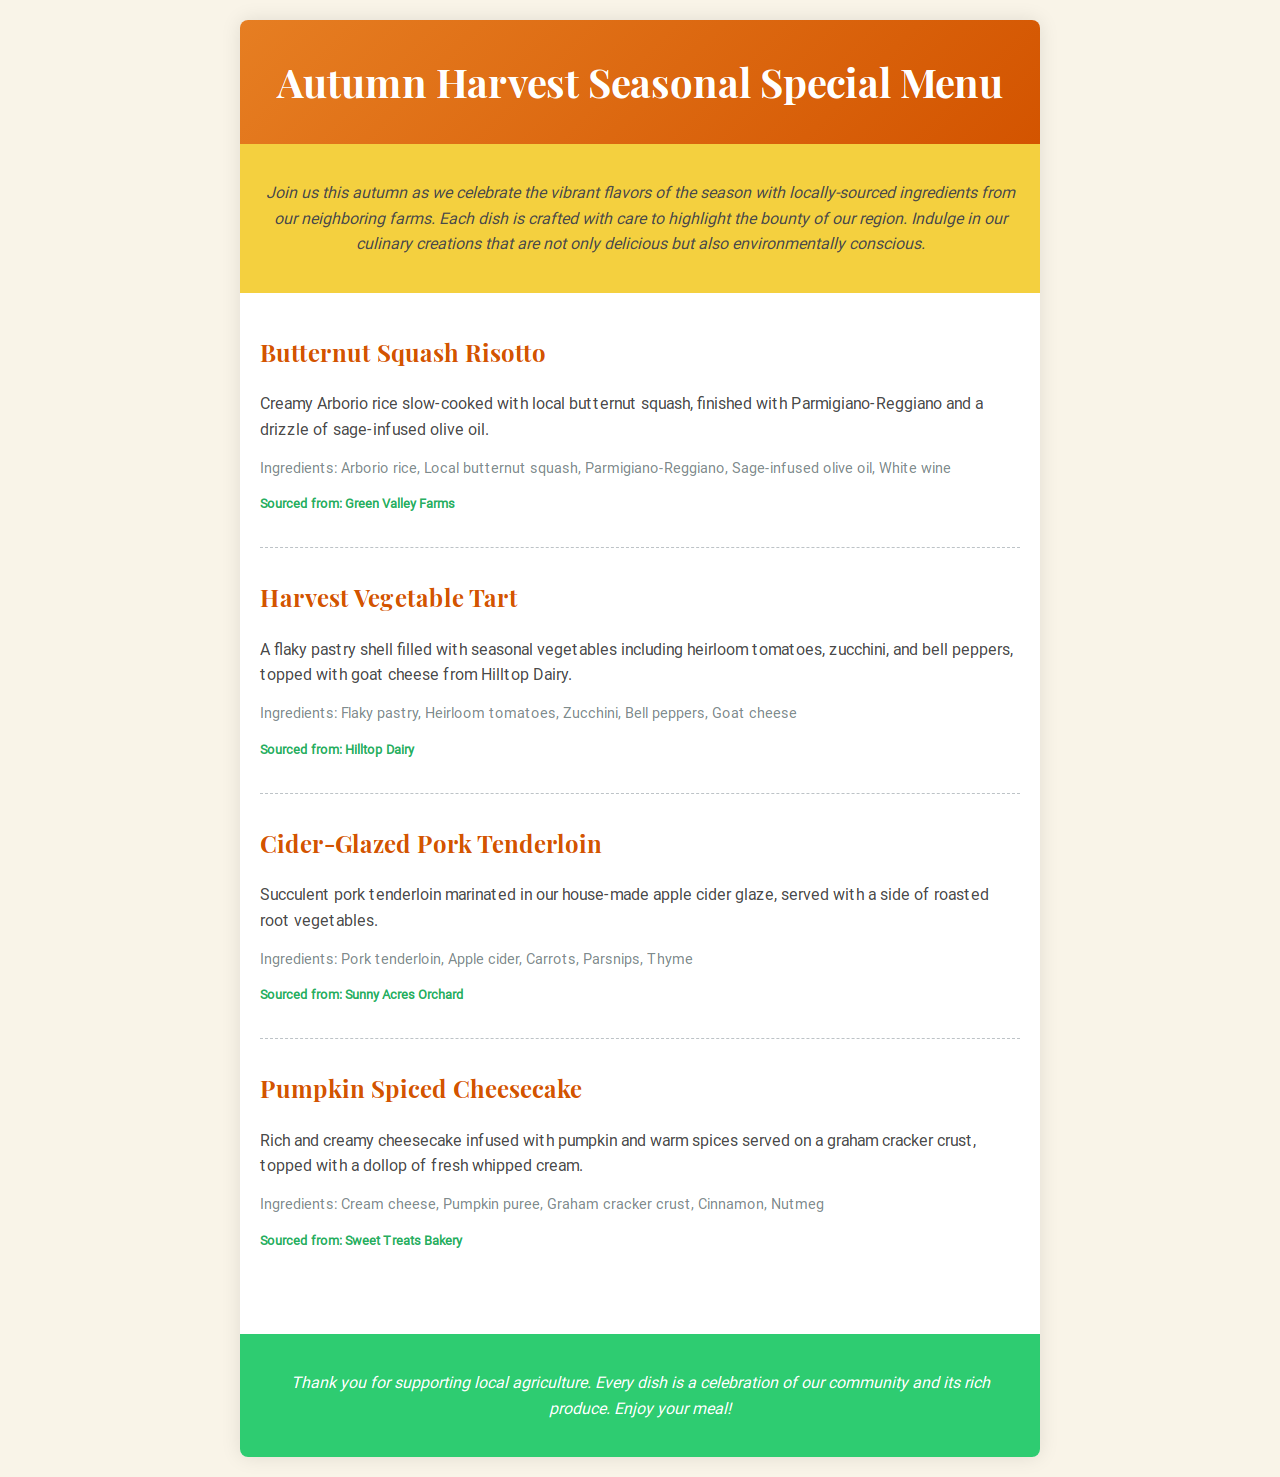What is the title of the menu? The title is prominently displayed at the top of the document, indicating the theme of the menu.
Answer: Autumn Harvest Seasonal Special Menu What kind of ingredients are highlighted in the menu? The introduction emphasizes the type of ingredients that are used in the dishes, which are sourced locally.
Answer: Locally-sourced ingredients Which dish includes goat cheese? This can be found in the description of the dish that specifically mentions goat cheese as an ingredient.
Answer: Harvest Vegetable Tart How many menu items are listed in the document? The count of menu items can be derived from how many dishes are detailed in the menu items section.
Answer: Four What farm is the pork tenderloin sourced from? The supplier information for the specific dish indicates where the ingredients were sourced.
Answer: Sunny Acres Orchard Which dish features white wine as an ingredient? The ingredients of each dish will help identify which one lists white wine.
Answer: Butternut Squash Risotto What is the closing note's background color? The closing note section likely contains a color that summarizes the section's theme or feels and can be described from the style portion of the document.
Answer: Green What is the main ingredient in the Pumpkin Spiced Cheesecake? The description of the dessert states the primary flavoring and can be found in the list of ingredients.
Answer: Pumpkin puree 